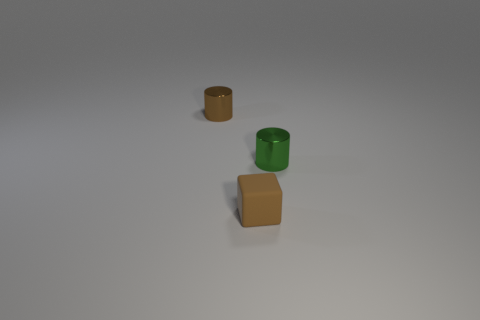Is there any other thing that is the same material as the small cube?
Ensure brevity in your answer.  No. Is there a thing of the same color as the matte cube?
Your answer should be compact. Yes. Are there an equal number of blocks to the left of the cube and green metal objects?
Your response must be concise. No. What size is the object that is behind the small matte cube and in front of the small brown metallic cylinder?
Ensure brevity in your answer.  Small. There is a small cylinder that is the same material as the green thing; what is its color?
Offer a very short reply. Brown. How many other tiny cylinders are the same material as the green cylinder?
Offer a terse response. 1. Are there an equal number of brown things to the right of the small matte block and brown blocks that are to the right of the brown cylinder?
Offer a terse response. No. Does the tiny brown rubber object have the same shape as the brown thing behind the green cylinder?
Offer a very short reply. No. There is a small cylinder that is the same color as the small cube; what material is it?
Keep it short and to the point. Metal. Are there any other things that are the same shape as the tiny rubber thing?
Keep it short and to the point. No. 